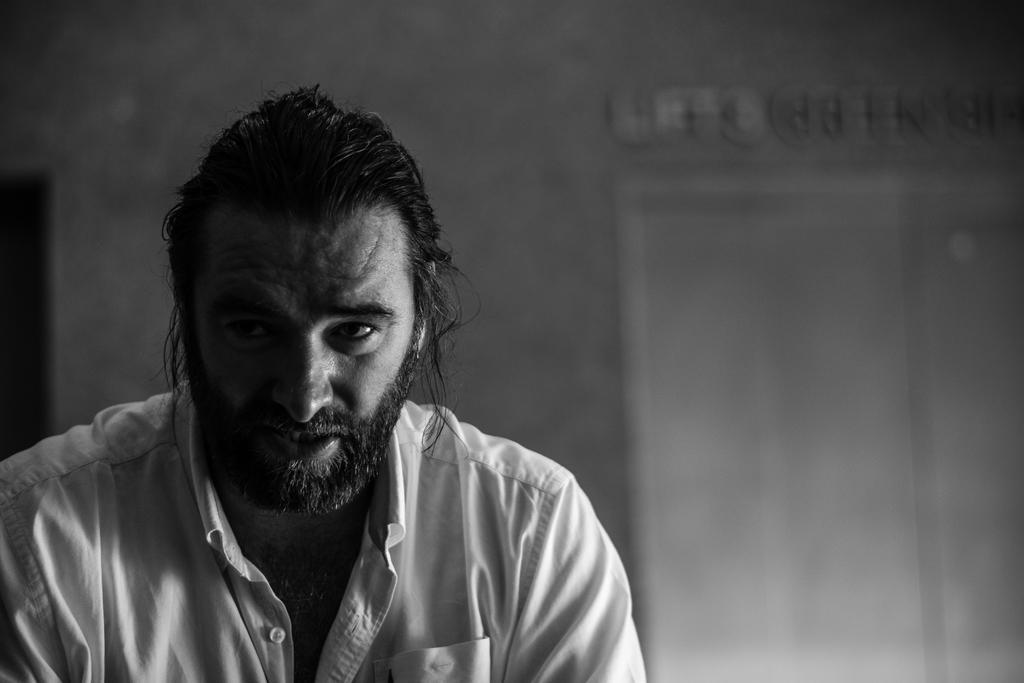Could you give a brief overview of what you see in this image? In this picture I can see a man and looks like a door in the back 